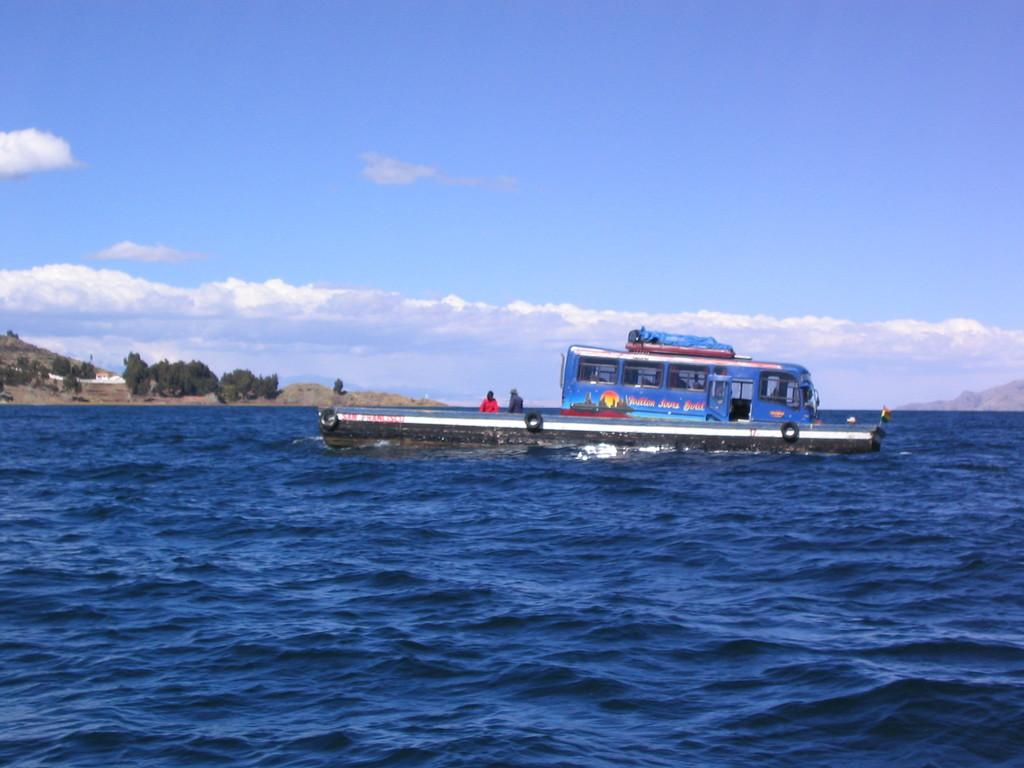What is in the foreground of the image? There is water in the foreground of the image. What is located in the water? There is a boat in the water. What can be seen on the left side of the image? There is land and trees on the left side of the image. What is visible in the sky? The sky is visible in the image, and it is partly cloudy with the sun shining. What is on the right side of the image? There is a hill on the right side of the image. How many brothers are visible in the image? There are no brothers present in the image. What is the size of the boat compared to the trees? The size of the boat cannot be determined in relation to the trees, as there is no reference point provided for comparison. 